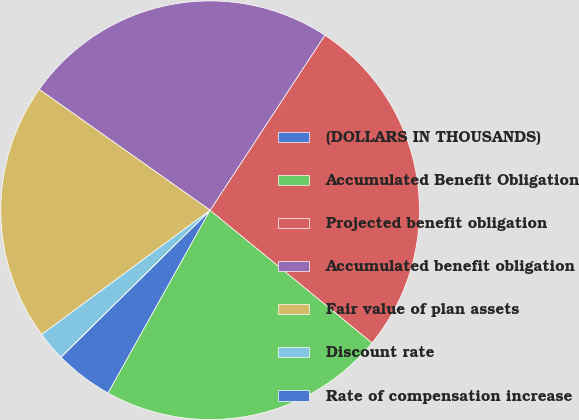Convert chart to OTSL. <chart><loc_0><loc_0><loc_500><loc_500><pie_chart><fcel>(DOLLARS IN THOUSANDS)<fcel>Accumulated Benefit Obligation<fcel>Projected benefit obligation<fcel>Accumulated benefit obligation<fcel>Fair value of plan assets<fcel>Discount rate<fcel>Rate of compensation increase<nl><fcel>4.52%<fcel>22.18%<fcel>26.69%<fcel>24.44%<fcel>19.92%<fcel>2.26%<fcel>0.0%<nl></chart> 